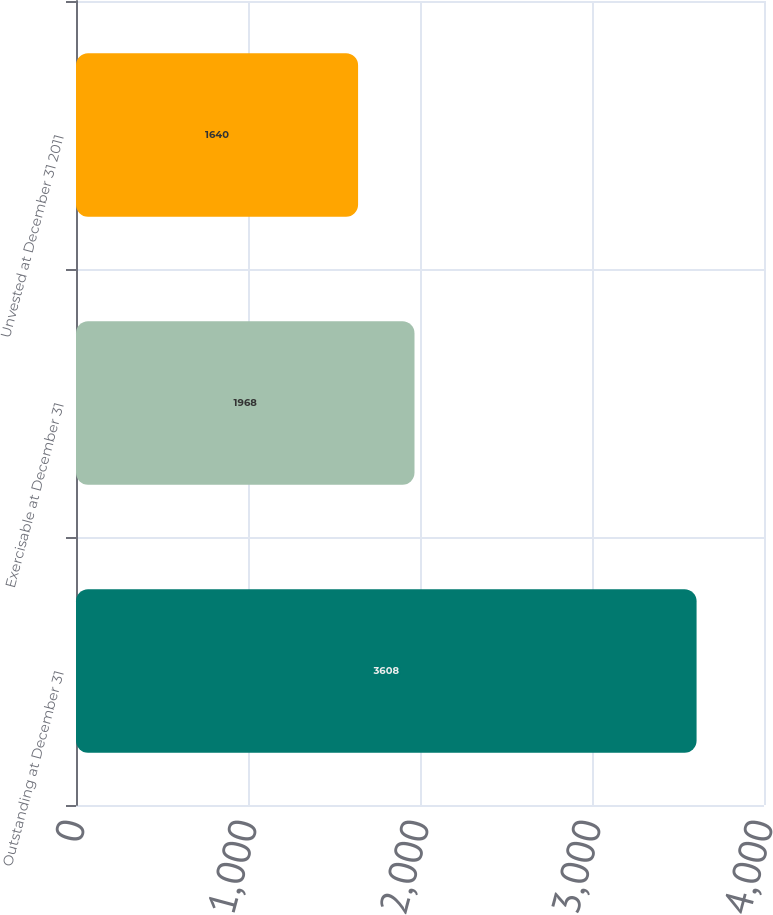Convert chart. <chart><loc_0><loc_0><loc_500><loc_500><bar_chart><fcel>Outstanding at December 31<fcel>Exercisable at December 31<fcel>Unvested at December 31 2011<nl><fcel>3608<fcel>1968<fcel>1640<nl></chart> 